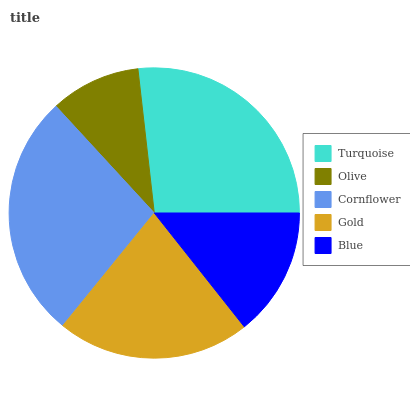Is Olive the minimum?
Answer yes or no. Yes. Is Cornflower the maximum?
Answer yes or no. Yes. Is Cornflower the minimum?
Answer yes or no. No. Is Olive the maximum?
Answer yes or no. No. Is Cornflower greater than Olive?
Answer yes or no. Yes. Is Olive less than Cornflower?
Answer yes or no. Yes. Is Olive greater than Cornflower?
Answer yes or no. No. Is Cornflower less than Olive?
Answer yes or no. No. Is Gold the high median?
Answer yes or no. Yes. Is Gold the low median?
Answer yes or no. Yes. Is Olive the high median?
Answer yes or no. No. Is Blue the low median?
Answer yes or no. No. 